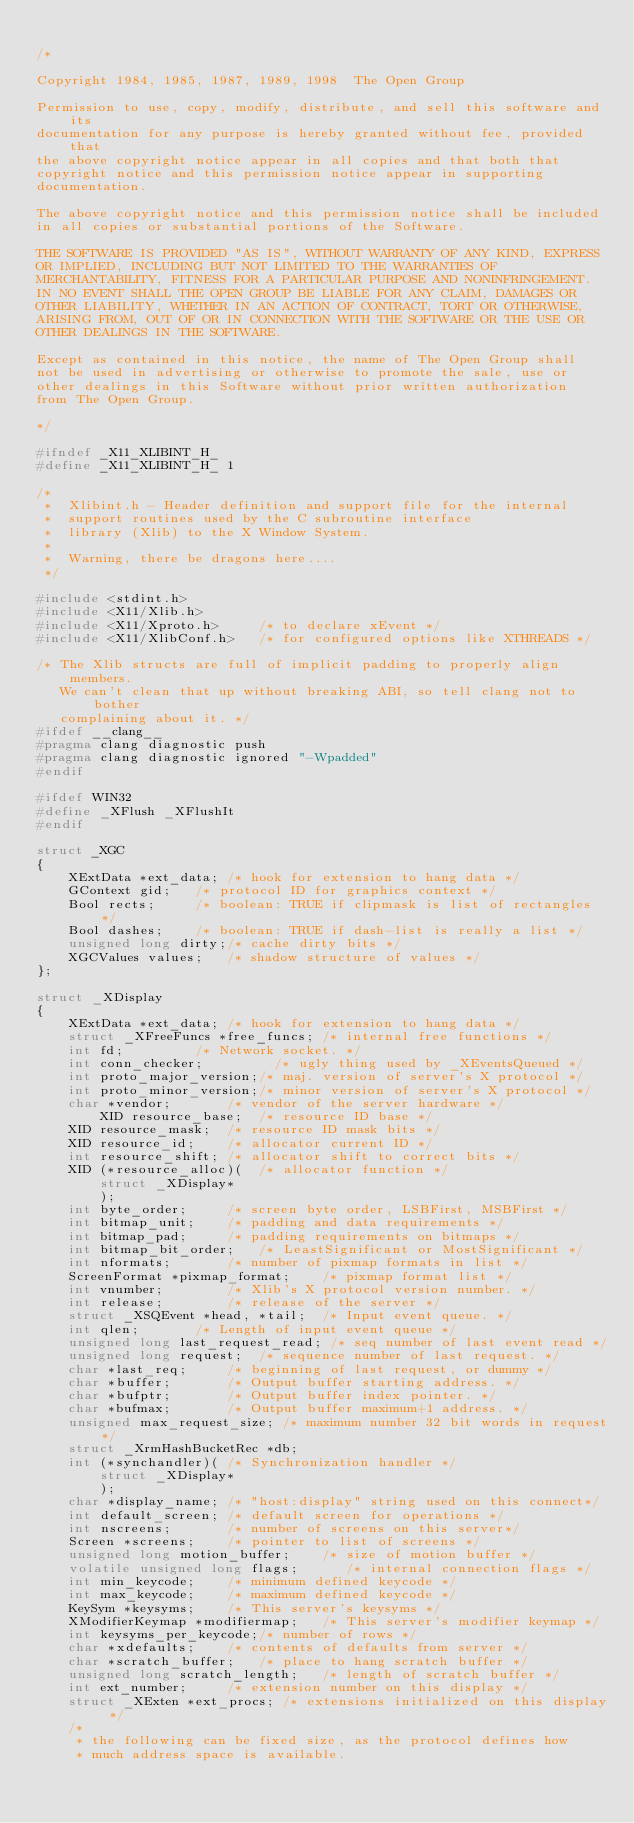Convert code to text. <code><loc_0><loc_0><loc_500><loc_500><_C_>
/*

Copyright 1984, 1985, 1987, 1989, 1998  The Open Group

Permission to use, copy, modify, distribute, and sell this software and its
documentation for any purpose is hereby granted without fee, provided that
the above copyright notice appear in all copies and that both that
copyright notice and this permission notice appear in supporting
documentation.

The above copyright notice and this permission notice shall be included
in all copies or substantial portions of the Software.

THE SOFTWARE IS PROVIDED "AS IS", WITHOUT WARRANTY OF ANY KIND, EXPRESS
OR IMPLIED, INCLUDING BUT NOT LIMITED TO THE WARRANTIES OF
MERCHANTABILITY, FITNESS FOR A PARTICULAR PURPOSE AND NONINFRINGEMENT.
IN NO EVENT SHALL THE OPEN GROUP BE LIABLE FOR ANY CLAIM, DAMAGES OR
OTHER LIABILITY, WHETHER IN AN ACTION OF CONTRACT, TORT OR OTHERWISE,
ARISING FROM, OUT OF OR IN CONNECTION WITH THE SOFTWARE OR THE USE OR
OTHER DEALINGS IN THE SOFTWARE.

Except as contained in this notice, the name of The Open Group shall
not be used in advertising or otherwise to promote the sale, use or
other dealings in this Software without prior written authorization
from The Open Group.

*/

#ifndef _X11_XLIBINT_H_
#define _X11_XLIBINT_H_ 1

/*
 *	Xlibint.h - Header definition and support file for the internal
 *	support routines used by the C subroutine interface
 *	library (Xlib) to the X Window System.
 *
 *	Warning, there be dragons here....
 */

#include <stdint.h>
#include <X11/Xlib.h>
#include <X11/Xproto.h>		/* to declare xEvent */
#include <X11/XlibConf.h>	/* for configured options like XTHREADS */

/* The Xlib structs are full of implicit padding to properly align members.
   We can't clean that up without breaking ABI, so tell clang not to bother
   complaining about it. */
#ifdef __clang__
#pragma clang diagnostic push
#pragma clang diagnostic ignored "-Wpadded"
#endif

#ifdef WIN32
#define _XFlush _XFlushIt
#endif

struct _XGC
{
    XExtData *ext_data;	/* hook for extension to hang data */
    GContext gid;	/* protocol ID for graphics context */
    Bool rects;		/* boolean: TRUE if clipmask is list of rectangles */
    Bool dashes;	/* boolean: TRUE if dash-list is really a list */
    unsigned long dirty;/* cache dirty bits */
    XGCValues values;	/* shadow structure of values */
};

struct _XDisplay
{
	XExtData *ext_data;	/* hook for extension to hang data */
	struct _XFreeFuncs *free_funcs; /* internal free functions */
	int fd;			/* Network socket. */
	int conn_checker;         /* ugly thing used by _XEventsQueued */
	int proto_major_version;/* maj. version of server's X protocol */
	int proto_minor_version;/* minor version of server's X protocol */
	char *vendor;		/* vendor of the server hardware */
        XID resource_base;	/* resource ID base */
	XID resource_mask;	/* resource ID mask bits */
	XID resource_id;	/* allocator current ID */
	int resource_shift;	/* allocator shift to correct bits */
	XID (*resource_alloc)(	/* allocator function */
		struct _XDisplay*
		);
	int byte_order;		/* screen byte order, LSBFirst, MSBFirst */
	int bitmap_unit;	/* padding and data requirements */
	int bitmap_pad;		/* padding requirements on bitmaps */
	int bitmap_bit_order;	/* LeastSignificant or MostSignificant */
	int nformats;		/* number of pixmap formats in list */
	ScreenFormat *pixmap_format;	/* pixmap format list */
	int vnumber;		/* Xlib's X protocol version number. */
	int release;		/* release of the server */
	struct _XSQEvent *head, *tail;	/* Input event queue. */
	int qlen;		/* Length of input event queue */
	unsigned long last_request_read; /* seq number of last event read */
	unsigned long request;	/* sequence number of last request. */
	char *last_req;		/* beginning of last request, or dummy */
	char *buffer;		/* Output buffer starting address. */
	char *bufptr;		/* Output buffer index pointer. */
	char *bufmax;		/* Output buffer maximum+1 address. */
	unsigned max_request_size; /* maximum number 32 bit words in request*/
	struct _XrmHashBucketRec *db;
	int (*synchandler)(	/* Synchronization handler */
		struct _XDisplay*
		);
	char *display_name;	/* "host:display" string used on this connect*/
	int default_screen;	/* default screen for operations */
	int nscreens;		/* number of screens on this server*/
	Screen *screens;	/* pointer to list of screens */
	unsigned long motion_buffer;	/* size of motion buffer */
	volatile unsigned long flags;	   /* internal connection flags */
	int min_keycode;	/* minimum defined keycode */
	int max_keycode;	/* maximum defined keycode */
	KeySym *keysyms;	/* This server's keysyms */
	XModifierKeymap *modifiermap;	/* This server's modifier keymap */
	int keysyms_per_keycode;/* number of rows */
	char *xdefaults;	/* contents of defaults from server */
	char *scratch_buffer;	/* place to hang scratch buffer */
	unsigned long scratch_length;	/* length of scratch buffer */
	int ext_number;		/* extension number on this display */
	struct _XExten *ext_procs; /* extensions initialized on this display */
	/*
	 * the following can be fixed size, as the protocol defines how
	 * much address space is available.</code> 